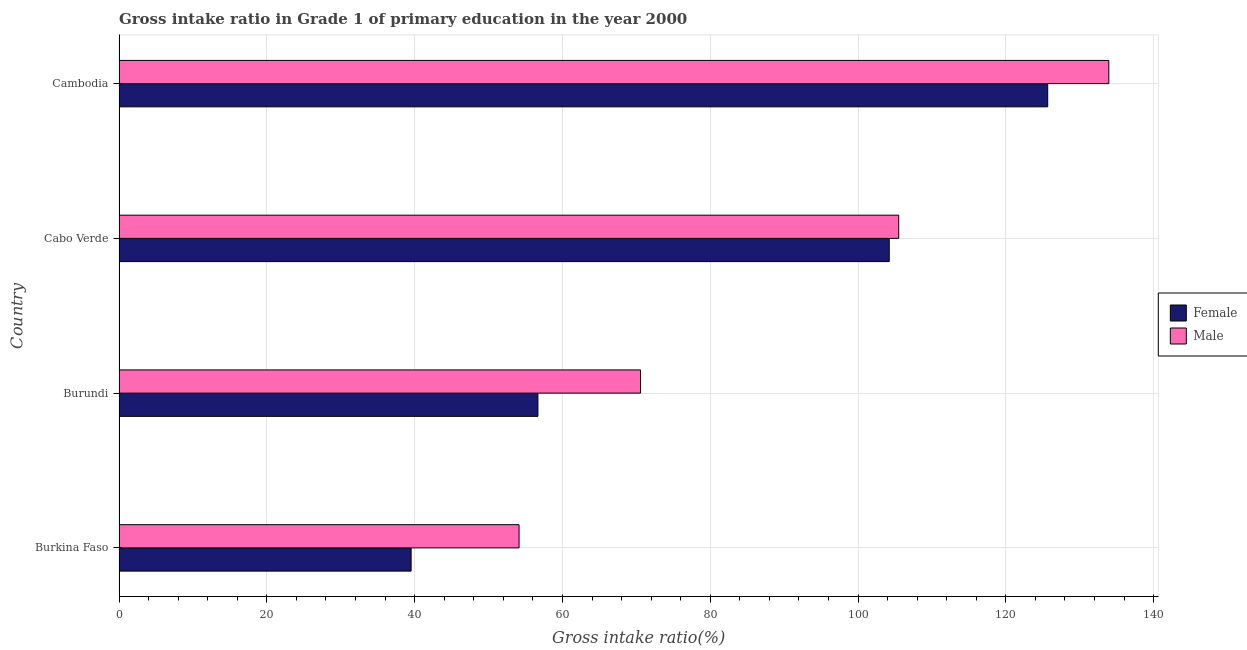How many different coloured bars are there?
Your answer should be compact. 2. Are the number of bars on each tick of the Y-axis equal?
Offer a very short reply. Yes. How many bars are there on the 3rd tick from the bottom?
Make the answer very short. 2. What is the label of the 2nd group of bars from the top?
Keep it short and to the point. Cabo Verde. In how many cases, is the number of bars for a given country not equal to the number of legend labels?
Offer a very short reply. 0. What is the gross intake ratio(male) in Burkina Faso?
Offer a terse response. 54.13. Across all countries, what is the maximum gross intake ratio(male)?
Offer a very short reply. 133.94. Across all countries, what is the minimum gross intake ratio(male)?
Make the answer very short. 54.13. In which country was the gross intake ratio(female) maximum?
Your answer should be compact. Cambodia. In which country was the gross intake ratio(female) minimum?
Your answer should be compact. Burkina Faso. What is the total gross intake ratio(male) in the graph?
Offer a very short reply. 364.14. What is the difference between the gross intake ratio(male) in Burkina Faso and that in Burundi?
Make the answer very short. -16.44. What is the difference between the gross intake ratio(female) in Cambodia and the gross intake ratio(male) in Burkina Faso?
Offer a very short reply. 71.54. What is the average gross intake ratio(male) per country?
Ensure brevity in your answer.  91.03. What is the difference between the gross intake ratio(male) and gross intake ratio(female) in Cabo Verde?
Your response must be concise. 1.28. In how many countries, is the gross intake ratio(female) greater than 40 %?
Ensure brevity in your answer.  3. What is the ratio of the gross intake ratio(female) in Burkina Faso to that in Cambodia?
Offer a very short reply. 0.32. What is the difference between the highest and the second highest gross intake ratio(male)?
Your answer should be very brief. 28.43. What is the difference between the highest and the lowest gross intake ratio(male)?
Provide a short and direct response. 79.81. In how many countries, is the gross intake ratio(male) greater than the average gross intake ratio(male) taken over all countries?
Your answer should be compact. 2. Is the sum of the gross intake ratio(female) in Burkina Faso and Cambodia greater than the maximum gross intake ratio(male) across all countries?
Provide a succinct answer. Yes. Are all the bars in the graph horizontal?
Provide a short and direct response. Yes. How many countries are there in the graph?
Keep it short and to the point. 4. Does the graph contain grids?
Your answer should be very brief. Yes. How many legend labels are there?
Give a very brief answer. 2. What is the title of the graph?
Provide a short and direct response. Gross intake ratio in Grade 1 of primary education in the year 2000. What is the label or title of the X-axis?
Make the answer very short. Gross intake ratio(%). What is the Gross intake ratio(%) in Female in Burkina Faso?
Offer a very short reply. 39.52. What is the Gross intake ratio(%) of Male in Burkina Faso?
Your answer should be compact. 54.13. What is the Gross intake ratio(%) in Female in Burundi?
Keep it short and to the point. 56.68. What is the Gross intake ratio(%) of Male in Burundi?
Provide a short and direct response. 70.57. What is the Gross intake ratio(%) in Female in Cabo Verde?
Ensure brevity in your answer.  104.22. What is the Gross intake ratio(%) of Male in Cabo Verde?
Provide a short and direct response. 105.51. What is the Gross intake ratio(%) in Female in Cambodia?
Provide a short and direct response. 125.67. What is the Gross intake ratio(%) in Male in Cambodia?
Your answer should be compact. 133.94. Across all countries, what is the maximum Gross intake ratio(%) of Female?
Provide a succinct answer. 125.67. Across all countries, what is the maximum Gross intake ratio(%) of Male?
Keep it short and to the point. 133.94. Across all countries, what is the minimum Gross intake ratio(%) in Female?
Provide a succinct answer. 39.52. Across all countries, what is the minimum Gross intake ratio(%) in Male?
Ensure brevity in your answer.  54.13. What is the total Gross intake ratio(%) in Female in the graph?
Offer a very short reply. 326.09. What is the total Gross intake ratio(%) in Male in the graph?
Keep it short and to the point. 364.14. What is the difference between the Gross intake ratio(%) in Female in Burkina Faso and that in Burundi?
Offer a very short reply. -17.16. What is the difference between the Gross intake ratio(%) of Male in Burkina Faso and that in Burundi?
Ensure brevity in your answer.  -16.44. What is the difference between the Gross intake ratio(%) in Female in Burkina Faso and that in Cabo Verde?
Give a very brief answer. -64.7. What is the difference between the Gross intake ratio(%) in Male in Burkina Faso and that in Cabo Verde?
Offer a terse response. -51.38. What is the difference between the Gross intake ratio(%) in Female in Burkina Faso and that in Cambodia?
Your response must be concise. -86.14. What is the difference between the Gross intake ratio(%) in Male in Burkina Faso and that in Cambodia?
Keep it short and to the point. -79.81. What is the difference between the Gross intake ratio(%) in Female in Burundi and that in Cabo Verde?
Provide a succinct answer. -47.54. What is the difference between the Gross intake ratio(%) in Male in Burundi and that in Cabo Verde?
Your response must be concise. -34.94. What is the difference between the Gross intake ratio(%) of Female in Burundi and that in Cambodia?
Offer a very short reply. -68.98. What is the difference between the Gross intake ratio(%) in Male in Burundi and that in Cambodia?
Give a very brief answer. -63.37. What is the difference between the Gross intake ratio(%) of Female in Cabo Verde and that in Cambodia?
Your answer should be very brief. -21.44. What is the difference between the Gross intake ratio(%) of Male in Cabo Verde and that in Cambodia?
Offer a terse response. -28.43. What is the difference between the Gross intake ratio(%) in Female in Burkina Faso and the Gross intake ratio(%) in Male in Burundi?
Your answer should be compact. -31.04. What is the difference between the Gross intake ratio(%) of Female in Burkina Faso and the Gross intake ratio(%) of Male in Cabo Verde?
Your answer should be compact. -65.98. What is the difference between the Gross intake ratio(%) of Female in Burkina Faso and the Gross intake ratio(%) of Male in Cambodia?
Your answer should be compact. -94.41. What is the difference between the Gross intake ratio(%) in Female in Burundi and the Gross intake ratio(%) in Male in Cabo Verde?
Ensure brevity in your answer.  -48.83. What is the difference between the Gross intake ratio(%) of Female in Burundi and the Gross intake ratio(%) of Male in Cambodia?
Provide a short and direct response. -77.25. What is the difference between the Gross intake ratio(%) of Female in Cabo Verde and the Gross intake ratio(%) of Male in Cambodia?
Offer a very short reply. -29.71. What is the average Gross intake ratio(%) of Female per country?
Offer a terse response. 81.52. What is the average Gross intake ratio(%) of Male per country?
Give a very brief answer. 91.03. What is the difference between the Gross intake ratio(%) of Female and Gross intake ratio(%) of Male in Burkina Faso?
Make the answer very short. -14.61. What is the difference between the Gross intake ratio(%) of Female and Gross intake ratio(%) of Male in Burundi?
Your response must be concise. -13.89. What is the difference between the Gross intake ratio(%) of Female and Gross intake ratio(%) of Male in Cabo Verde?
Your answer should be compact. -1.28. What is the difference between the Gross intake ratio(%) of Female and Gross intake ratio(%) of Male in Cambodia?
Offer a terse response. -8.27. What is the ratio of the Gross intake ratio(%) in Female in Burkina Faso to that in Burundi?
Your answer should be very brief. 0.7. What is the ratio of the Gross intake ratio(%) in Male in Burkina Faso to that in Burundi?
Your response must be concise. 0.77. What is the ratio of the Gross intake ratio(%) of Female in Burkina Faso to that in Cabo Verde?
Ensure brevity in your answer.  0.38. What is the ratio of the Gross intake ratio(%) in Male in Burkina Faso to that in Cabo Verde?
Offer a very short reply. 0.51. What is the ratio of the Gross intake ratio(%) in Female in Burkina Faso to that in Cambodia?
Give a very brief answer. 0.31. What is the ratio of the Gross intake ratio(%) of Male in Burkina Faso to that in Cambodia?
Offer a terse response. 0.4. What is the ratio of the Gross intake ratio(%) in Female in Burundi to that in Cabo Verde?
Your answer should be compact. 0.54. What is the ratio of the Gross intake ratio(%) of Male in Burundi to that in Cabo Verde?
Make the answer very short. 0.67. What is the ratio of the Gross intake ratio(%) in Female in Burundi to that in Cambodia?
Give a very brief answer. 0.45. What is the ratio of the Gross intake ratio(%) of Male in Burundi to that in Cambodia?
Make the answer very short. 0.53. What is the ratio of the Gross intake ratio(%) of Female in Cabo Verde to that in Cambodia?
Your answer should be compact. 0.83. What is the ratio of the Gross intake ratio(%) of Male in Cabo Verde to that in Cambodia?
Give a very brief answer. 0.79. What is the difference between the highest and the second highest Gross intake ratio(%) of Female?
Provide a succinct answer. 21.44. What is the difference between the highest and the second highest Gross intake ratio(%) in Male?
Provide a succinct answer. 28.43. What is the difference between the highest and the lowest Gross intake ratio(%) of Female?
Provide a short and direct response. 86.14. What is the difference between the highest and the lowest Gross intake ratio(%) in Male?
Provide a short and direct response. 79.81. 